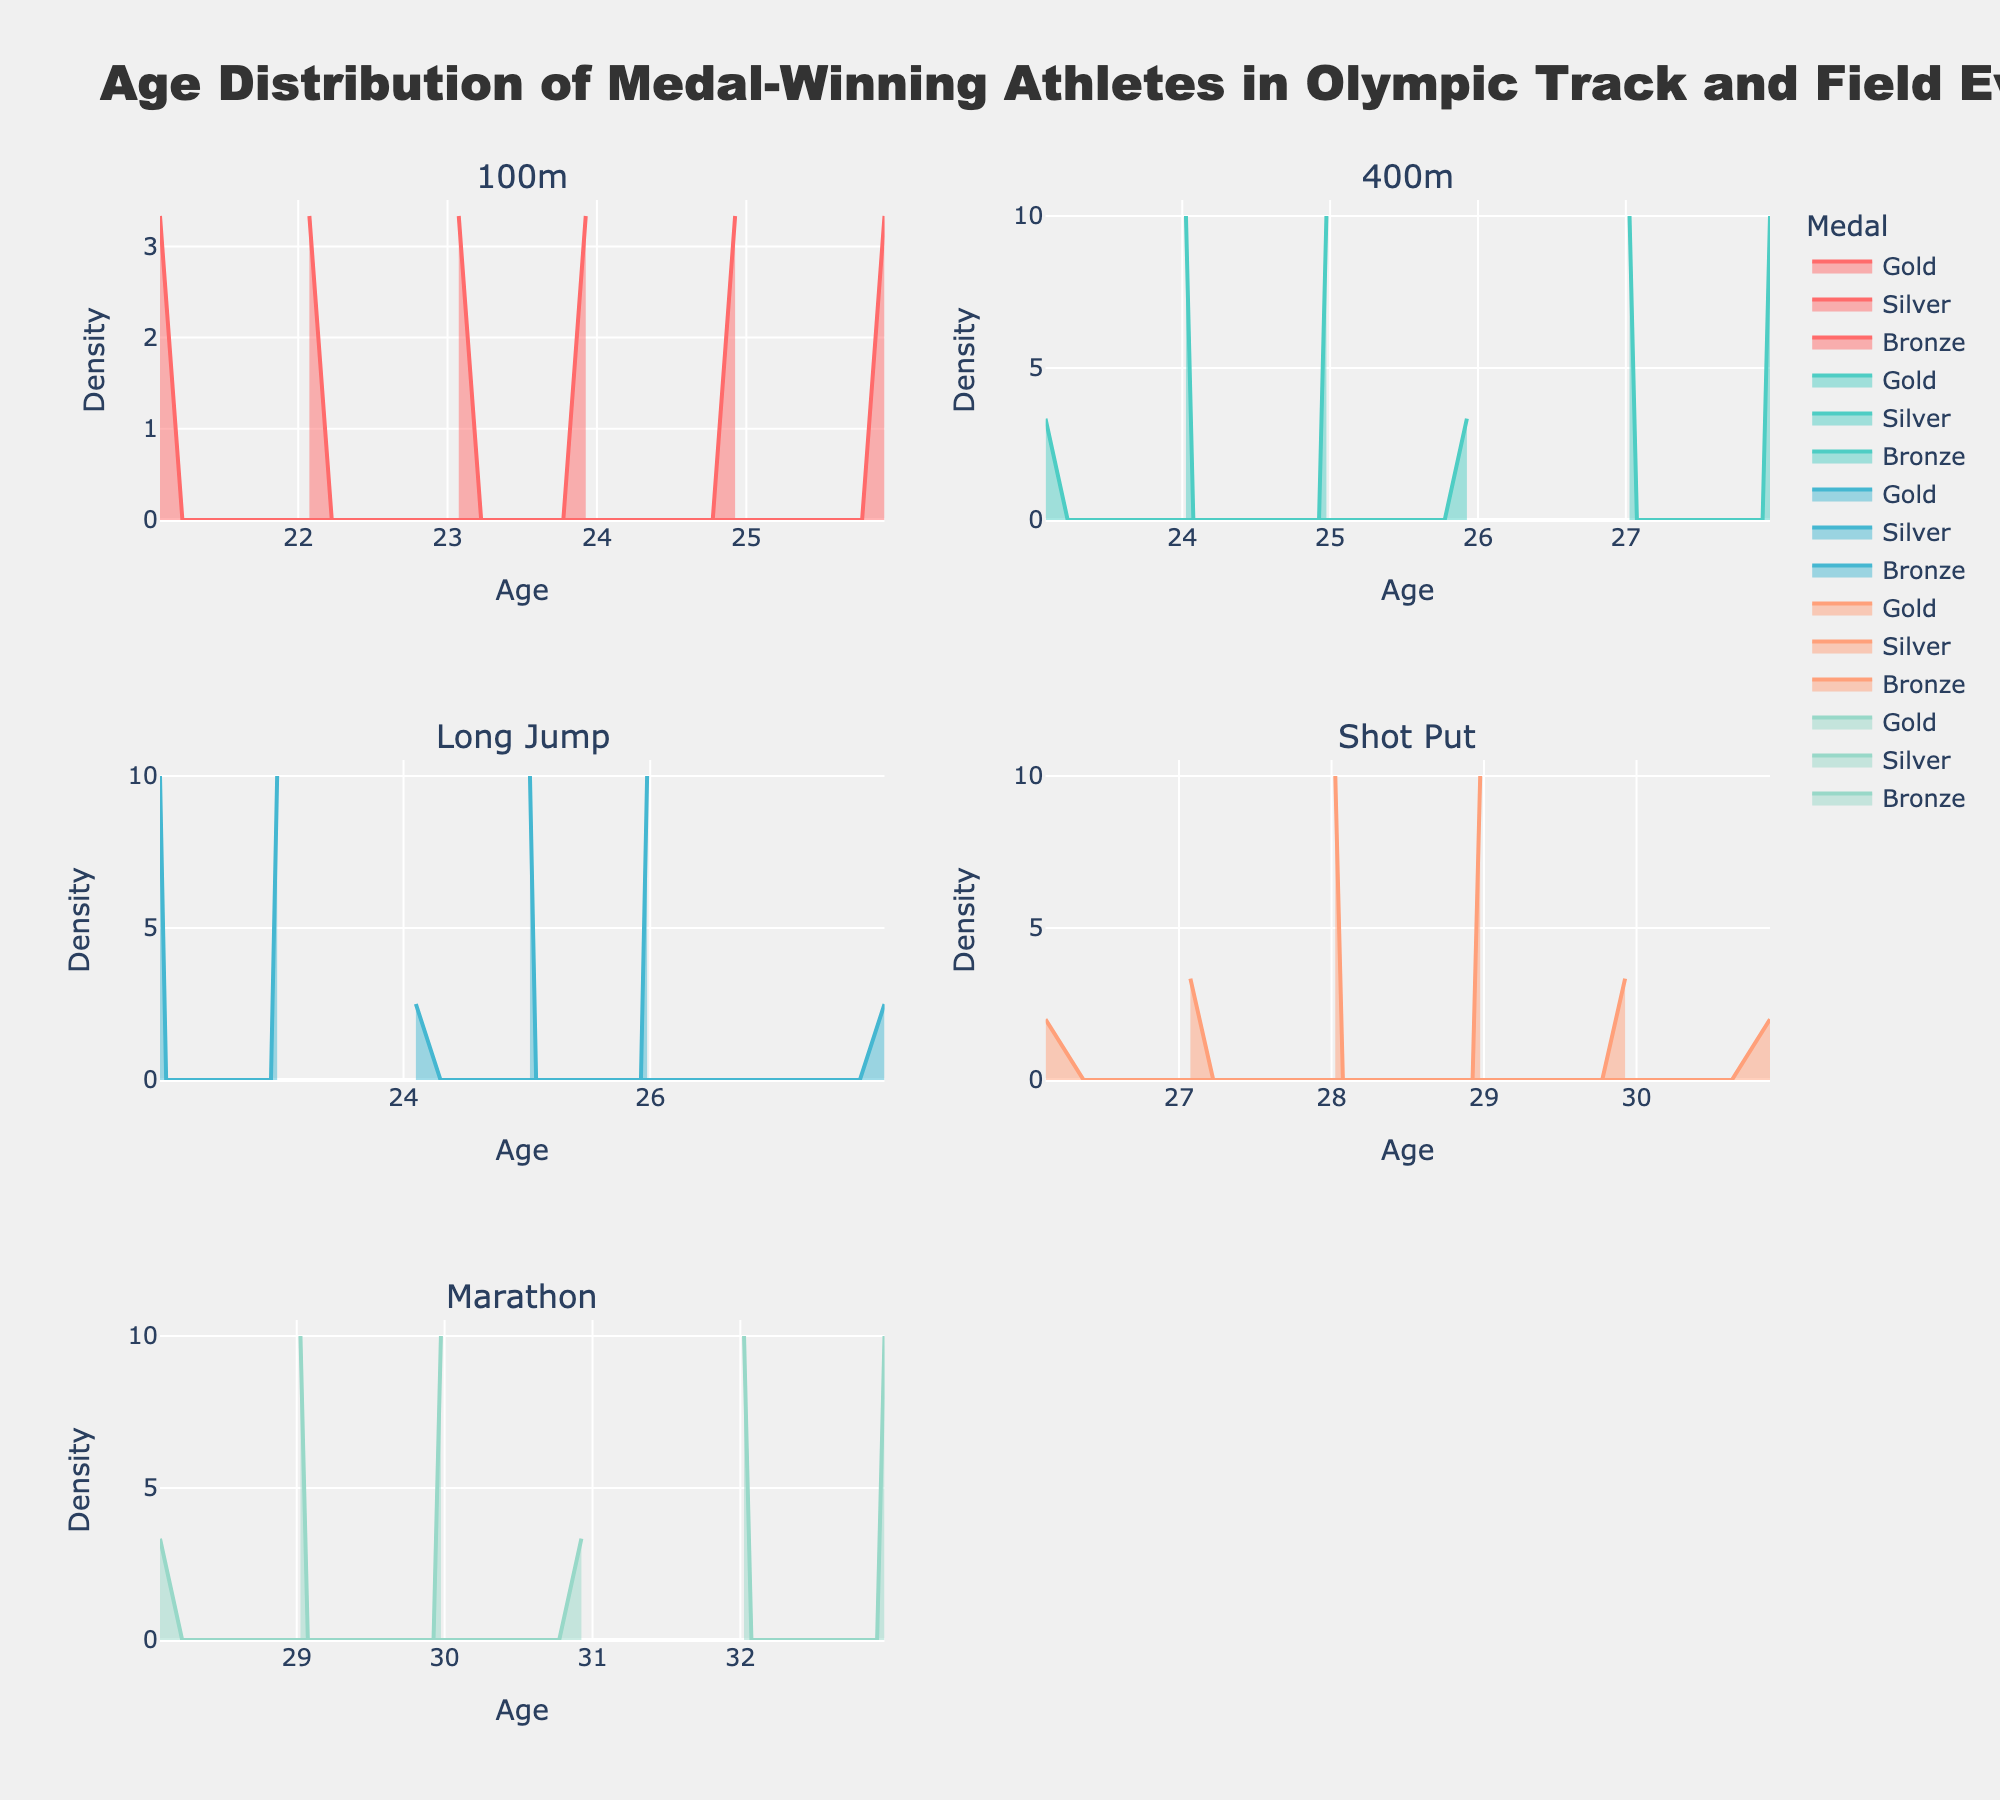What is the title of the plot? The title of the plot is prominently displayed at the top of the figure.
Answer: Age Distribution of Medal-Winning Athletes in Olympic Track and Field Events Which event has the oldest median age for medal winners? By visually inspecting the density plots, the biggest peak (highest density) occurring at the highest age is for the Marathon event.
Answer: Marathon What is the shape of the age distribution for Gold medalists in the 100m event? Look at the density plot for the 100m event. The distribution is shown by a curve that may have a single peak or multiple peaks. For the Gold medalists, the density plot appears to have a single peak.
Answer: Single peak How does the age distribution for Shot Put medalists differ from that of Long Jump medalists? Compare the shape and spread of the density plots for Shot Put and Long Jump. Shot Put medalists have a wider age distribution, with peaks toward the older age group, whereas Long Jump medalists tend to have a narrower and slightly younger age distribution.
Answer: Shot Put has a wider and older spread; Long Jump is narrower and younger Which event has the most spread out ages for Silver medalists? Observe the density plots for Silver medalists in each event and assess their spread. The Shot Put density plot for Silver medalists shows the most spread out distribution.
Answer: Shot Put What age do Bronze medalists in the Marathon event tend to be? Review the density plot corresponding to Bronze medalists in the Marathon event. The density plot has a peak around a certain age, indicating the tendency.
Answer: Around 31 Are the age distributions for Gold and Bronze medalists in 400m overlapping? Examine the density plots for Gold and Bronze medalists in the 400m event. Look for overlapping regions where both plots show similar density values.
Answer: Yes, they overlap Which medal type has the narrowest age range in Long Jump? Observe the density plots for all medal types in the Long Jump event. The medal type with the sharpest and tallest peak (indicating a narrow range) has the narrowest age range. This appears to be the Bronze medal.
Answer: Bronze In which event is there the most uniform distribution of ages across medalists? The event with density plots having close to a uniform spread across different medal types shows a more uniform age distribution. Marathon and Long Jump can be compared to see which has less prominent peaks and a wider spread.
Answer: Marathon 